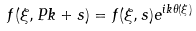Convert formula to latex. <formula><loc_0><loc_0><loc_500><loc_500>f ( \xi , P k + s ) & = f ( \xi , s ) e ^ { i k \theta ( \xi ) } \\</formula> 